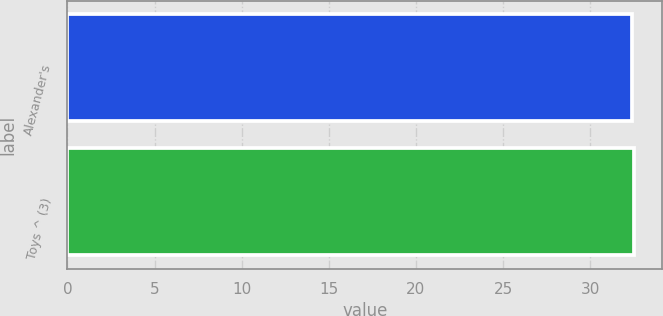Convert chart to OTSL. <chart><loc_0><loc_0><loc_500><loc_500><bar_chart><fcel>Alexander's<fcel>Toys ^ (3)<nl><fcel>32.4<fcel>32.5<nl></chart> 